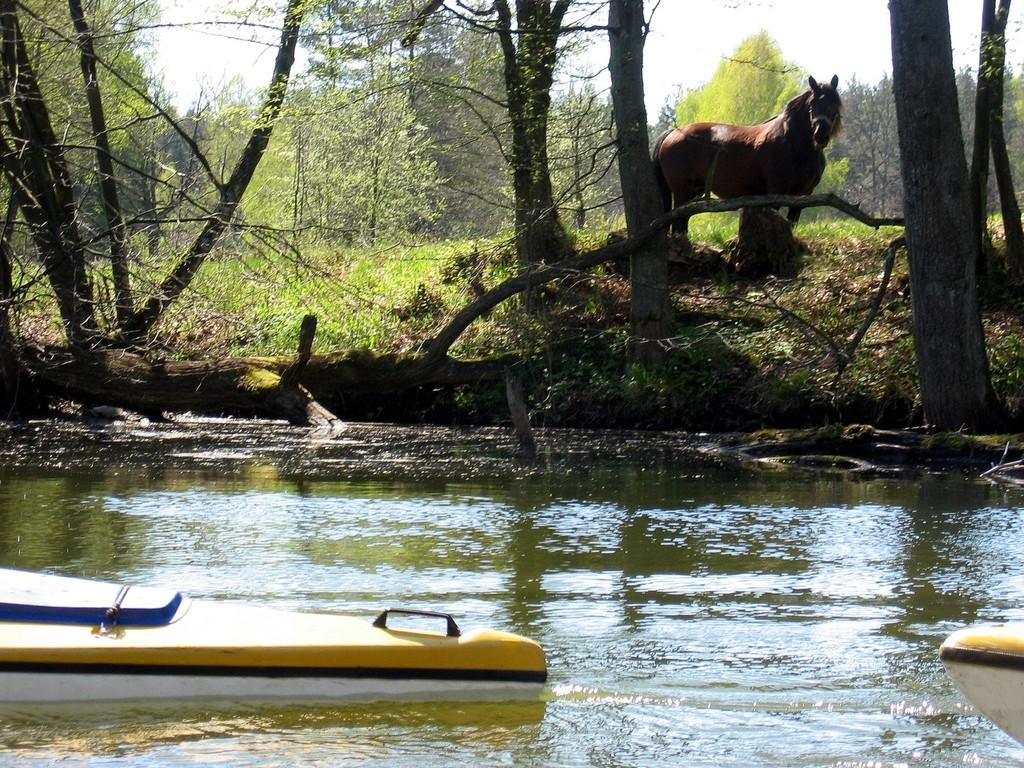What animal can be seen in the image? There is a horse in the image. What natural element is present in the image? Water is visible in the image. What activity is taking place on the water? Boats are sailing on the water. What type of vegetation is present in the image? There is grass, trees, and plants in the image. What part of the natural environment is visible in the image? The sky is visible in the image. What type of vegetable is being stretched by the horse in the image? There is no vegetable present in the image, nor is the horse stretching anything. 